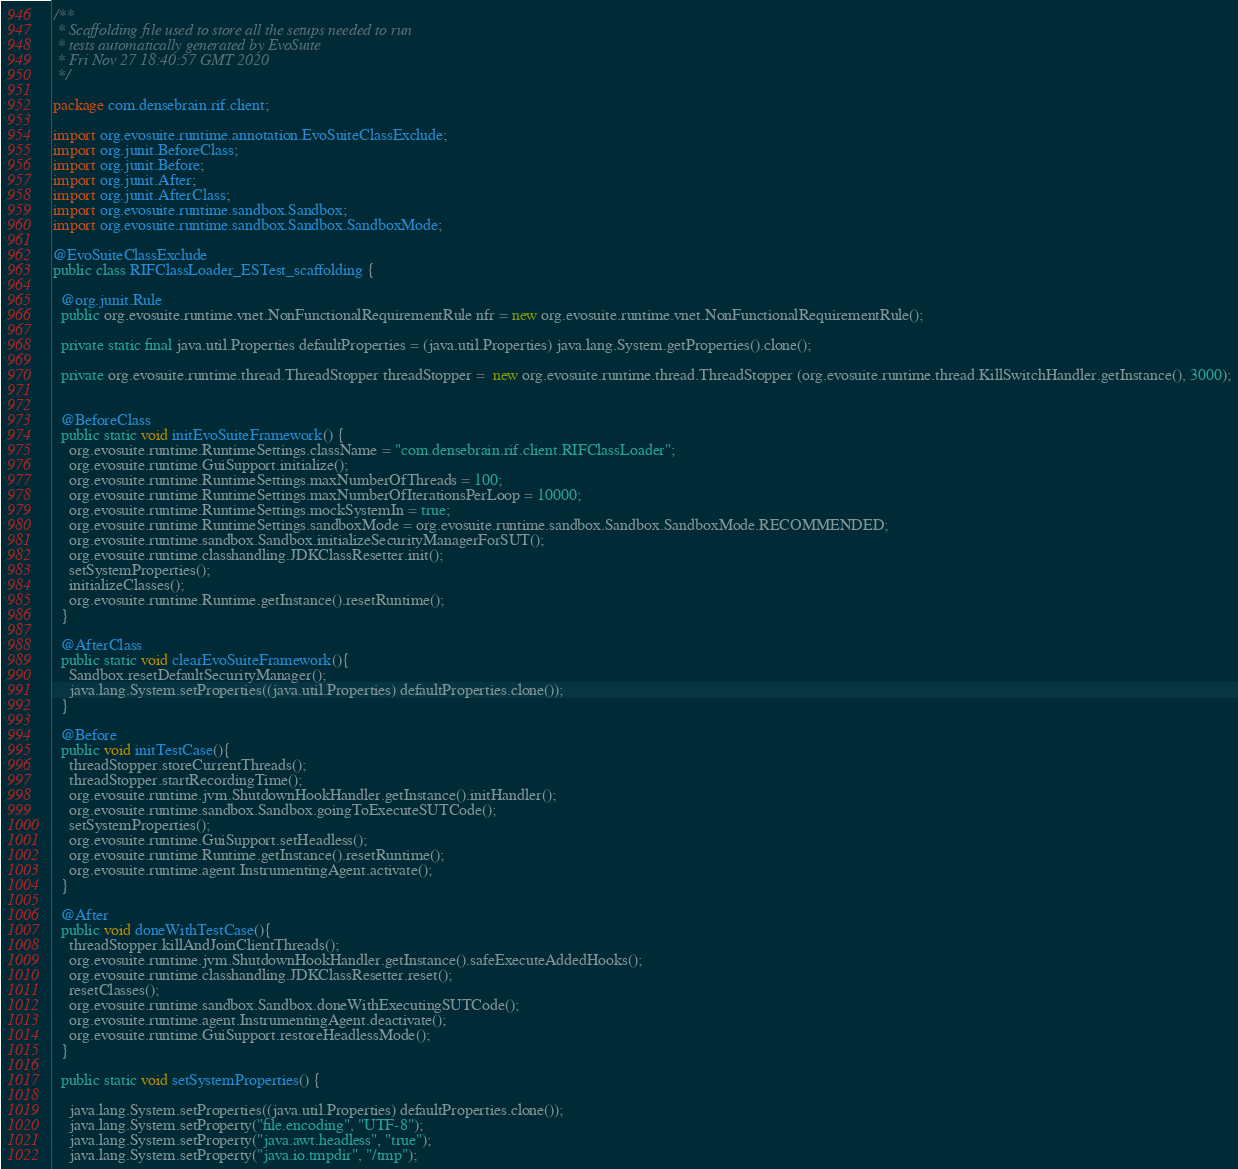<code> <loc_0><loc_0><loc_500><loc_500><_Java_>/**
 * Scaffolding file used to store all the setups needed to run 
 * tests automatically generated by EvoSuite
 * Fri Nov 27 18:40:57 GMT 2020
 */

package com.densebrain.rif.client;

import org.evosuite.runtime.annotation.EvoSuiteClassExclude;
import org.junit.BeforeClass;
import org.junit.Before;
import org.junit.After;
import org.junit.AfterClass;
import org.evosuite.runtime.sandbox.Sandbox;
import org.evosuite.runtime.sandbox.Sandbox.SandboxMode;

@EvoSuiteClassExclude
public class RIFClassLoader_ESTest_scaffolding {

  @org.junit.Rule 
  public org.evosuite.runtime.vnet.NonFunctionalRequirementRule nfr = new org.evosuite.runtime.vnet.NonFunctionalRequirementRule();

  private static final java.util.Properties defaultProperties = (java.util.Properties) java.lang.System.getProperties().clone(); 

  private org.evosuite.runtime.thread.ThreadStopper threadStopper =  new org.evosuite.runtime.thread.ThreadStopper (org.evosuite.runtime.thread.KillSwitchHandler.getInstance(), 3000);


  @BeforeClass 
  public static void initEvoSuiteFramework() { 
    org.evosuite.runtime.RuntimeSettings.className = "com.densebrain.rif.client.RIFClassLoader"; 
    org.evosuite.runtime.GuiSupport.initialize(); 
    org.evosuite.runtime.RuntimeSettings.maxNumberOfThreads = 100; 
    org.evosuite.runtime.RuntimeSettings.maxNumberOfIterationsPerLoop = 10000; 
    org.evosuite.runtime.RuntimeSettings.mockSystemIn = true; 
    org.evosuite.runtime.RuntimeSettings.sandboxMode = org.evosuite.runtime.sandbox.Sandbox.SandboxMode.RECOMMENDED; 
    org.evosuite.runtime.sandbox.Sandbox.initializeSecurityManagerForSUT(); 
    org.evosuite.runtime.classhandling.JDKClassResetter.init();
    setSystemProperties();
    initializeClasses();
    org.evosuite.runtime.Runtime.getInstance().resetRuntime(); 
  } 

  @AfterClass 
  public static void clearEvoSuiteFramework(){ 
    Sandbox.resetDefaultSecurityManager(); 
    java.lang.System.setProperties((java.util.Properties) defaultProperties.clone()); 
  } 

  @Before 
  public void initTestCase(){ 
    threadStopper.storeCurrentThreads();
    threadStopper.startRecordingTime();
    org.evosuite.runtime.jvm.ShutdownHookHandler.getInstance().initHandler(); 
    org.evosuite.runtime.sandbox.Sandbox.goingToExecuteSUTCode(); 
    setSystemProperties(); 
    org.evosuite.runtime.GuiSupport.setHeadless(); 
    org.evosuite.runtime.Runtime.getInstance().resetRuntime(); 
    org.evosuite.runtime.agent.InstrumentingAgent.activate(); 
  } 

  @After 
  public void doneWithTestCase(){ 
    threadStopper.killAndJoinClientThreads();
    org.evosuite.runtime.jvm.ShutdownHookHandler.getInstance().safeExecuteAddedHooks(); 
    org.evosuite.runtime.classhandling.JDKClassResetter.reset(); 
    resetClasses(); 
    org.evosuite.runtime.sandbox.Sandbox.doneWithExecutingSUTCode(); 
    org.evosuite.runtime.agent.InstrumentingAgent.deactivate(); 
    org.evosuite.runtime.GuiSupport.restoreHeadlessMode(); 
  } 

  public static void setSystemProperties() {
 
    java.lang.System.setProperties((java.util.Properties) defaultProperties.clone()); 
    java.lang.System.setProperty("file.encoding", "UTF-8"); 
    java.lang.System.setProperty("java.awt.headless", "true"); 
    java.lang.System.setProperty("java.io.tmpdir", "/tmp"); </code> 